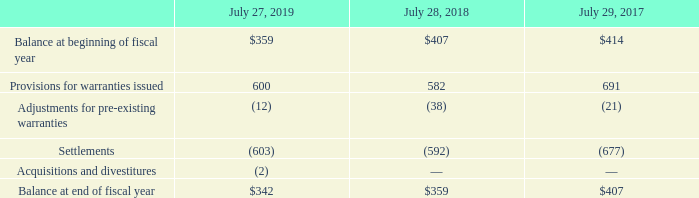(d) Product Warranties
The following table summarizes the activity related to the product warranty liability (in millions):
We accrue for warranty costs as part of our cost of sales based on associated material product costs, labor costs for technical support staff, and associated overhead. Our products are generally covered by a warranty for periods ranging from 90 days to five years, and for some products we provide a limited lifetime warranty.
How does the company accrue for warranty costs? As part of our cost of sales based on associated material product costs, labor costs for technical support staff, and associated overhead. Which years does the table provide information for the company's activity related to their product warranty liability? 2019, 2018, 2017. What were the Acquisitions and divestitures in 2019?
Answer scale should be: million. (2). What was the change in Provisions for warranties issued between 2017 and 2018?
Answer scale should be: million. 582-691
Answer: -109. How many years did the Balance at beginning of fiscal year exceed $400 million? 2018##2017
Answer: 2. What was the percentage change in the Balance at end of fiscal year between 2018 and 2019?
Answer scale should be: percent. (342-359)/359
Answer: -4.74. 